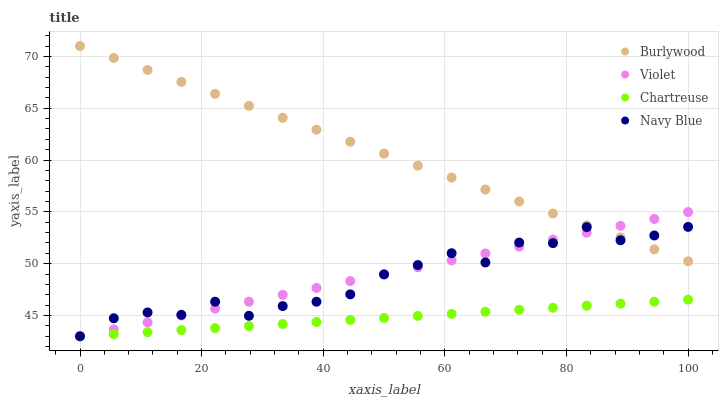Does Chartreuse have the minimum area under the curve?
Answer yes or no. Yes. Does Burlywood have the maximum area under the curve?
Answer yes or no. Yes. Does Navy Blue have the minimum area under the curve?
Answer yes or no. No. Does Navy Blue have the maximum area under the curve?
Answer yes or no. No. Is Chartreuse the smoothest?
Answer yes or no. Yes. Is Navy Blue the roughest?
Answer yes or no. Yes. Is Navy Blue the smoothest?
Answer yes or no. No. Is Chartreuse the roughest?
Answer yes or no. No. Does Navy Blue have the lowest value?
Answer yes or no. Yes. Does Burlywood have the highest value?
Answer yes or no. Yes. Does Navy Blue have the highest value?
Answer yes or no. No. Is Chartreuse less than Burlywood?
Answer yes or no. Yes. Is Burlywood greater than Chartreuse?
Answer yes or no. Yes. Does Burlywood intersect Violet?
Answer yes or no. Yes. Is Burlywood less than Violet?
Answer yes or no. No. Is Burlywood greater than Violet?
Answer yes or no. No. Does Chartreuse intersect Burlywood?
Answer yes or no. No. 